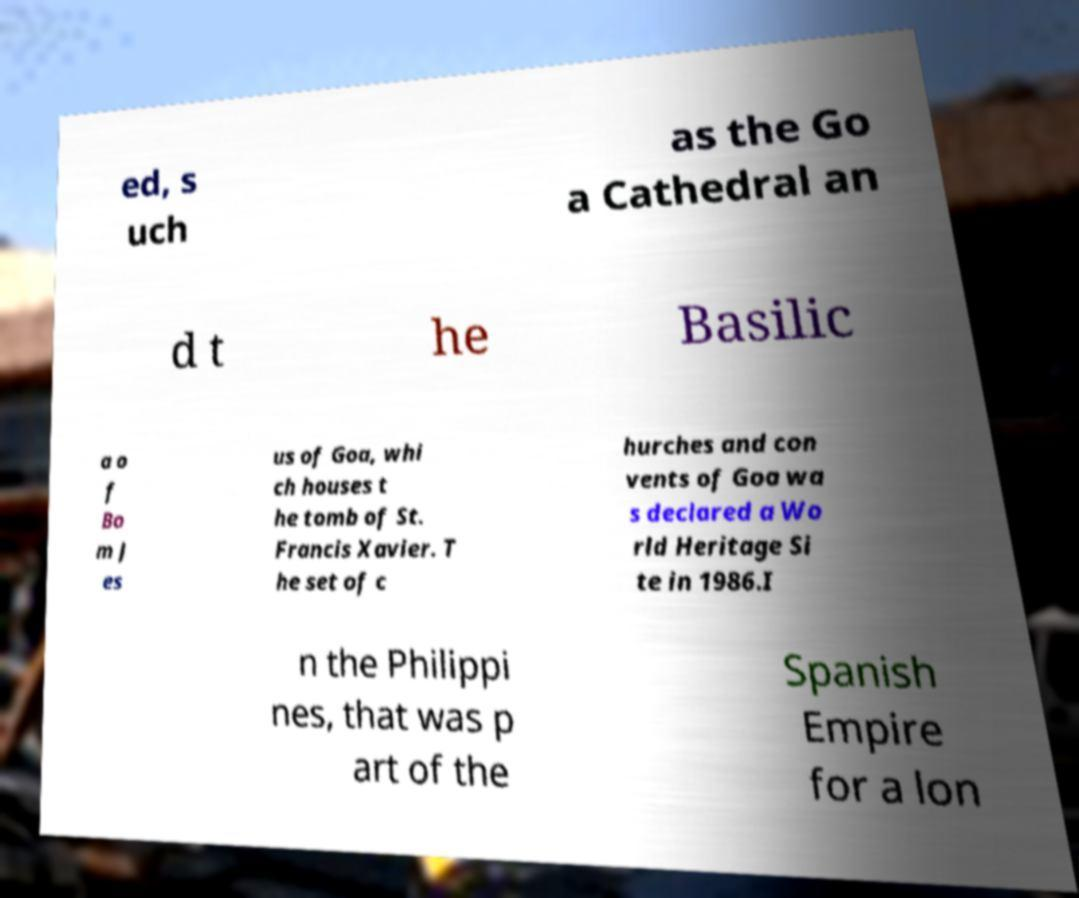What messages or text are displayed in this image? I need them in a readable, typed format. ed, s uch as the Go a Cathedral an d t he Basilic a o f Bo m J es us of Goa, whi ch houses t he tomb of St. Francis Xavier. T he set of c hurches and con vents of Goa wa s declared a Wo rld Heritage Si te in 1986.I n the Philippi nes, that was p art of the Spanish Empire for a lon 